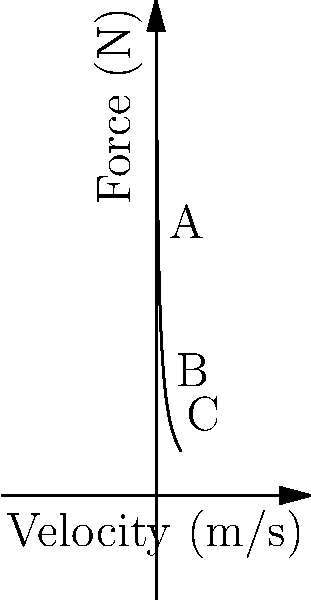As a program officer evaluating a biomechanics research project, you're presented with a force-velocity curve of muscle contraction. Which point on the curve represents the highest power output of the muscle, and how does this information relate to the efficiency of movement in the proposed study? To answer this question, we need to understand the force-velocity relationship and its implications for muscle power output:

1. The force-velocity curve shows an inverse relationship between force and velocity in muscle contraction.

2. Power is the product of force and velocity: $P = F \times v$

3. On the graph:
   - Point A: High force, low velocity
   - Point B: Moderate force, moderate velocity
   - Point C: Low force, high velocity

4. The point of highest power output is where the product of force and velocity is maximized. This typically occurs at approximately 1/3 of the maximum shortening velocity.

5. Visually, point B appears to be closest to this optimal point, representing a balance between force and velocity.

6. In terms of movement efficiency:
   - High force (A) is useful for lifting heavy loads but is less efficient for continuous movement.
   - High velocity (C) is good for rapid movements but can't sustain high forces.
   - The balanced point (B) is most efficient for sustained, powerful movements.

7. For the proposed study, this information is crucial as it helps in understanding:
   - How muscles perform under different load conditions
   - The optimal conditions for various types of movement
   - How to design interventions or training programs to improve movement efficiency
Answer: Point B; it represents the optimal balance of force and velocity for maximum power output, which is crucial for understanding and improving movement efficiency in biomechanics research. 